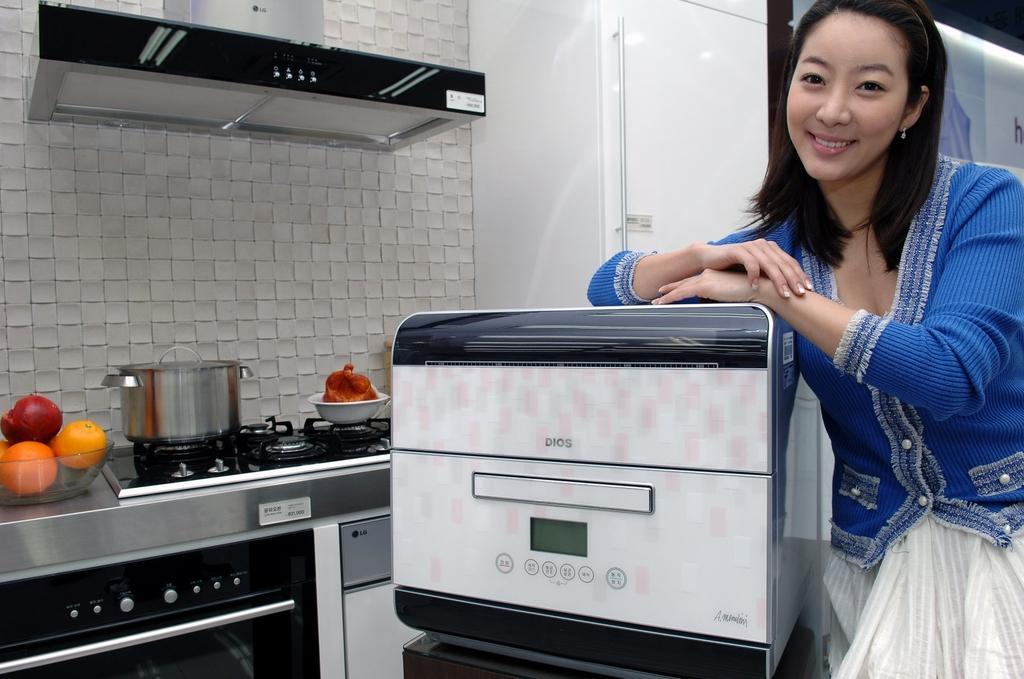How would you summarize this image in a sentence or two? In this there is a women standing near a micro oven, beside that there is a stove, near the stove there is a bowl, in that bowl there are fruits and there is a chimney. 